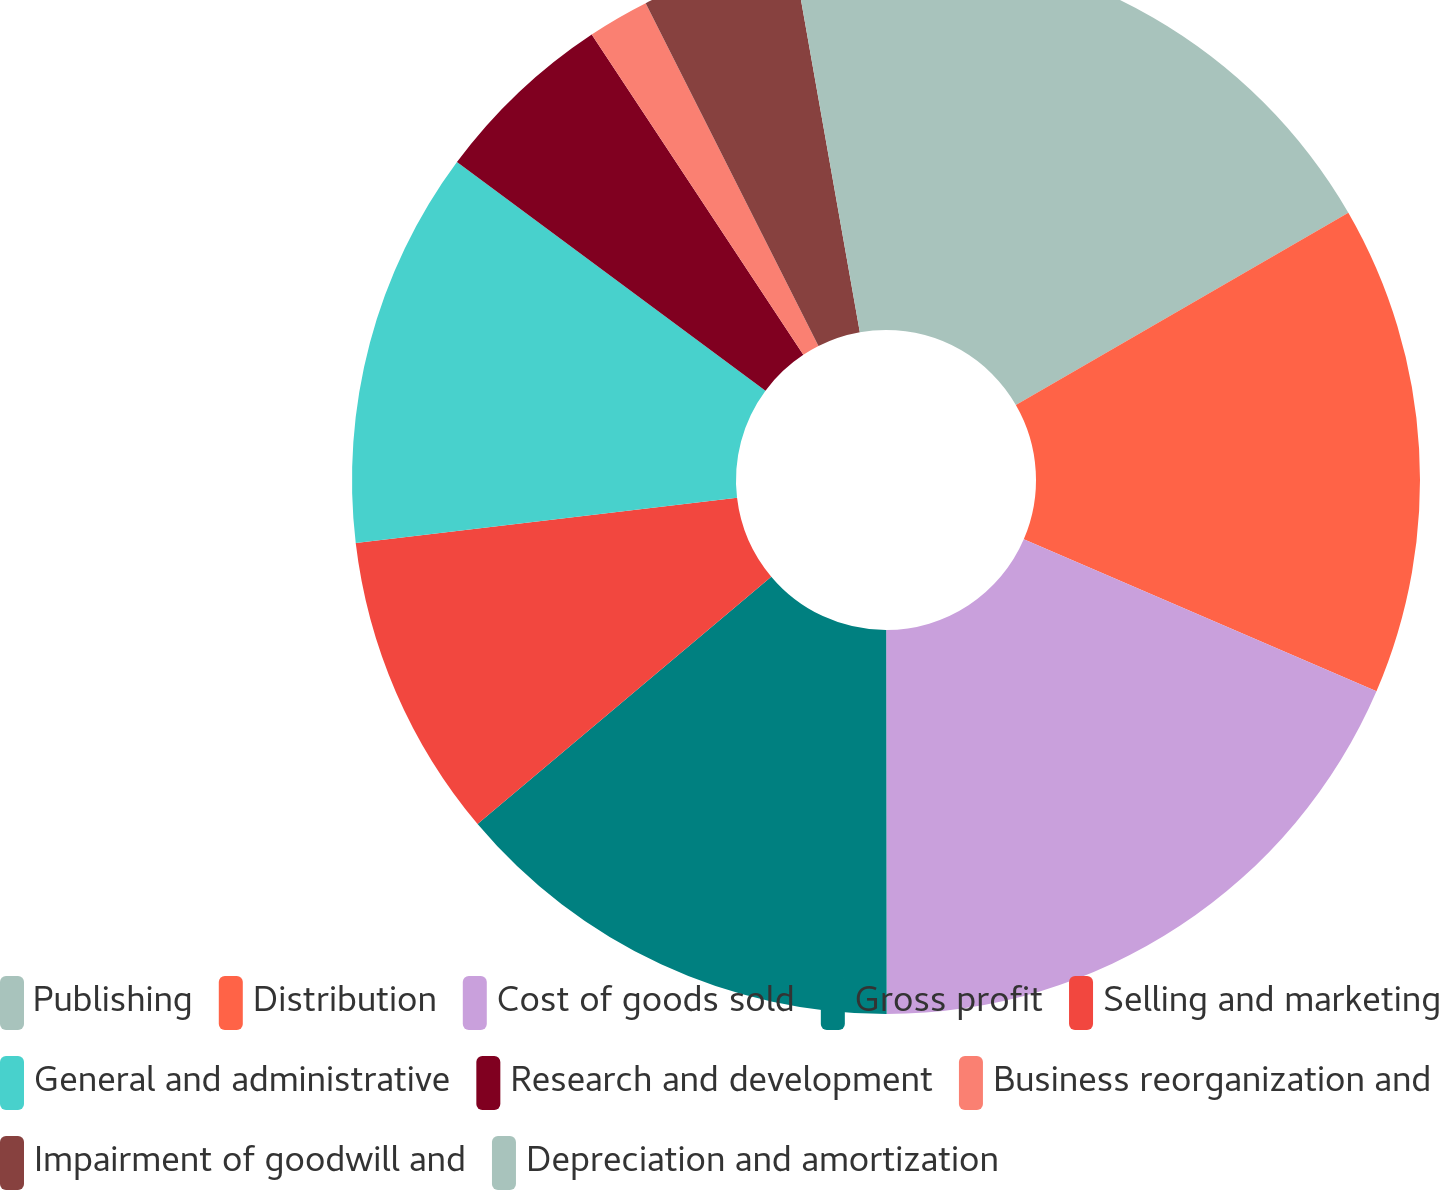Convert chart. <chart><loc_0><loc_0><loc_500><loc_500><pie_chart><fcel>Publishing<fcel>Distribution<fcel>Cost of goods sold<fcel>Gross profit<fcel>Selling and marketing<fcel>General and administrative<fcel>Research and development<fcel>Business reorganization and<fcel>Impairment of goodwill and<fcel>Depreciation and amortization<nl><fcel>16.66%<fcel>14.81%<fcel>18.51%<fcel>13.88%<fcel>9.26%<fcel>12.03%<fcel>5.56%<fcel>1.86%<fcel>4.64%<fcel>2.79%<nl></chart> 